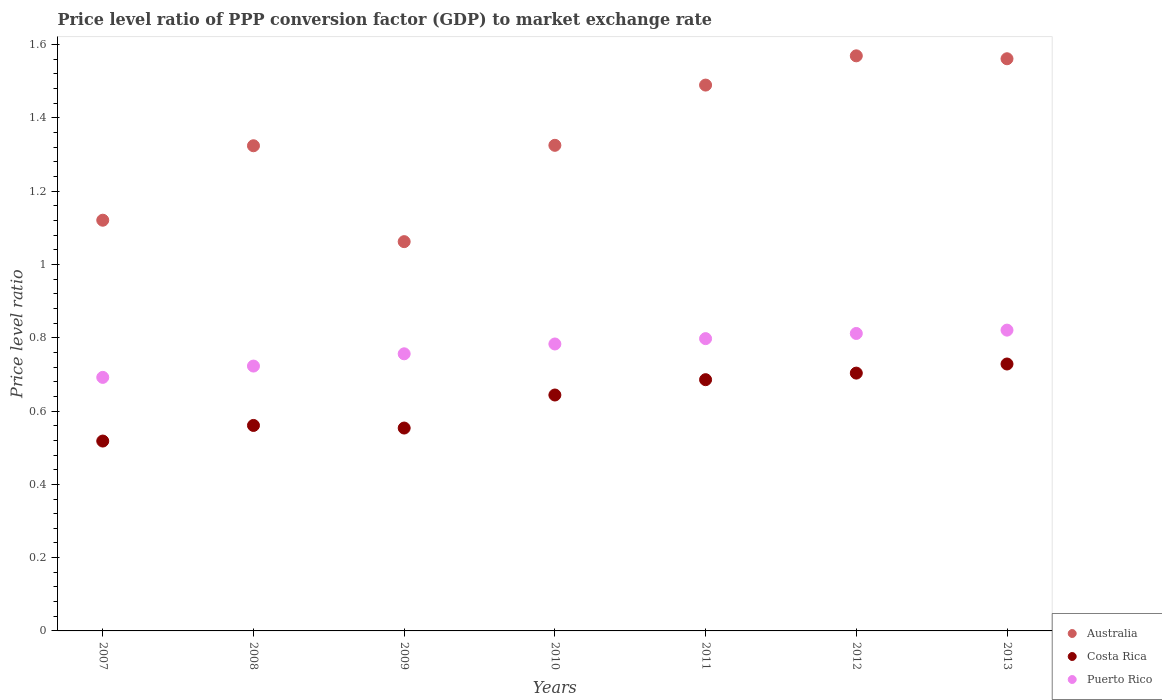Is the number of dotlines equal to the number of legend labels?
Your answer should be very brief. Yes. What is the price level ratio in Costa Rica in 2009?
Offer a very short reply. 0.55. Across all years, what is the maximum price level ratio in Costa Rica?
Ensure brevity in your answer.  0.73. Across all years, what is the minimum price level ratio in Puerto Rico?
Provide a succinct answer. 0.69. In which year was the price level ratio in Costa Rica minimum?
Provide a short and direct response. 2007. What is the total price level ratio in Puerto Rico in the graph?
Your answer should be compact. 5.38. What is the difference between the price level ratio in Australia in 2010 and that in 2013?
Provide a succinct answer. -0.24. What is the difference between the price level ratio in Puerto Rico in 2013 and the price level ratio in Australia in 2009?
Ensure brevity in your answer.  -0.24. What is the average price level ratio in Australia per year?
Make the answer very short. 1.35. In the year 2007, what is the difference between the price level ratio in Australia and price level ratio in Puerto Rico?
Provide a succinct answer. 0.43. In how many years, is the price level ratio in Australia greater than 0.7200000000000001?
Keep it short and to the point. 7. What is the ratio of the price level ratio in Puerto Rico in 2009 to that in 2011?
Give a very brief answer. 0.95. What is the difference between the highest and the second highest price level ratio in Australia?
Your answer should be compact. 0.01. What is the difference between the highest and the lowest price level ratio in Puerto Rico?
Your answer should be very brief. 0.13. In how many years, is the price level ratio in Costa Rica greater than the average price level ratio in Costa Rica taken over all years?
Provide a succinct answer. 4. Is the price level ratio in Costa Rica strictly greater than the price level ratio in Puerto Rico over the years?
Your response must be concise. No. Is the price level ratio in Australia strictly less than the price level ratio in Costa Rica over the years?
Offer a terse response. No. What is the difference between two consecutive major ticks on the Y-axis?
Your response must be concise. 0.2. Are the values on the major ticks of Y-axis written in scientific E-notation?
Your response must be concise. No. Does the graph contain grids?
Your answer should be very brief. No. Where does the legend appear in the graph?
Make the answer very short. Bottom right. What is the title of the graph?
Offer a terse response. Price level ratio of PPP conversion factor (GDP) to market exchange rate. What is the label or title of the X-axis?
Provide a short and direct response. Years. What is the label or title of the Y-axis?
Offer a very short reply. Price level ratio. What is the Price level ratio in Australia in 2007?
Your answer should be compact. 1.12. What is the Price level ratio of Costa Rica in 2007?
Provide a short and direct response. 0.52. What is the Price level ratio of Puerto Rico in 2007?
Keep it short and to the point. 0.69. What is the Price level ratio in Australia in 2008?
Keep it short and to the point. 1.32. What is the Price level ratio of Costa Rica in 2008?
Your answer should be compact. 0.56. What is the Price level ratio of Puerto Rico in 2008?
Ensure brevity in your answer.  0.72. What is the Price level ratio in Australia in 2009?
Offer a terse response. 1.06. What is the Price level ratio in Costa Rica in 2009?
Keep it short and to the point. 0.55. What is the Price level ratio of Puerto Rico in 2009?
Offer a very short reply. 0.76. What is the Price level ratio in Australia in 2010?
Provide a succinct answer. 1.33. What is the Price level ratio of Costa Rica in 2010?
Your answer should be compact. 0.64. What is the Price level ratio in Puerto Rico in 2010?
Offer a very short reply. 0.78. What is the Price level ratio of Australia in 2011?
Offer a very short reply. 1.49. What is the Price level ratio of Costa Rica in 2011?
Make the answer very short. 0.69. What is the Price level ratio in Puerto Rico in 2011?
Keep it short and to the point. 0.8. What is the Price level ratio in Australia in 2012?
Offer a terse response. 1.57. What is the Price level ratio of Costa Rica in 2012?
Offer a terse response. 0.7. What is the Price level ratio of Puerto Rico in 2012?
Provide a short and direct response. 0.81. What is the Price level ratio of Australia in 2013?
Ensure brevity in your answer.  1.56. What is the Price level ratio of Costa Rica in 2013?
Your answer should be compact. 0.73. What is the Price level ratio in Puerto Rico in 2013?
Give a very brief answer. 0.82. Across all years, what is the maximum Price level ratio of Australia?
Offer a terse response. 1.57. Across all years, what is the maximum Price level ratio of Costa Rica?
Make the answer very short. 0.73. Across all years, what is the maximum Price level ratio of Puerto Rico?
Offer a terse response. 0.82. Across all years, what is the minimum Price level ratio of Australia?
Offer a very short reply. 1.06. Across all years, what is the minimum Price level ratio in Costa Rica?
Offer a terse response. 0.52. Across all years, what is the minimum Price level ratio in Puerto Rico?
Offer a terse response. 0.69. What is the total Price level ratio of Australia in the graph?
Give a very brief answer. 9.45. What is the total Price level ratio of Costa Rica in the graph?
Provide a succinct answer. 4.39. What is the total Price level ratio in Puerto Rico in the graph?
Your response must be concise. 5.38. What is the difference between the Price level ratio of Australia in 2007 and that in 2008?
Provide a succinct answer. -0.2. What is the difference between the Price level ratio of Costa Rica in 2007 and that in 2008?
Offer a very short reply. -0.04. What is the difference between the Price level ratio of Puerto Rico in 2007 and that in 2008?
Your answer should be very brief. -0.03. What is the difference between the Price level ratio in Australia in 2007 and that in 2009?
Keep it short and to the point. 0.06. What is the difference between the Price level ratio of Costa Rica in 2007 and that in 2009?
Provide a succinct answer. -0.04. What is the difference between the Price level ratio in Puerto Rico in 2007 and that in 2009?
Keep it short and to the point. -0.06. What is the difference between the Price level ratio in Australia in 2007 and that in 2010?
Offer a very short reply. -0.2. What is the difference between the Price level ratio of Costa Rica in 2007 and that in 2010?
Provide a short and direct response. -0.13. What is the difference between the Price level ratio in Puerto Rico in 2007 and that in 2010?
Make the answer very short. -0.09. What is the difference between the Price level ratio of Australia in 2007 and that in 2011?
Provide a succinct answer. -0.37. What is the difference between the Price level ratio of Costa Rica in 2007 and that in 2011?
Give a very brief answer. -0.17. What is the difference between the Price level ratio in Puerto Rico in 2007 and that in 2011?
Your response must be concise. -0.11. What is the difference between the Price level ratio in Australia in 2007 and that in 2012?
Your answer should be compact. -0.45. What is the difference between the Price level ratio in Costa Rica in 2007 and that in 2012?
Offer a terse response. -0.19. What is the difference between the Price level ratio of Puerto Rico in 2007 and that in 2012?
Your response must be concise. -0.12. What is the difference between the Price level ratio in Australia in 2007 and that in 2013?
Provide a succinct answer. -0.44. What is the difference between the Price level ratio of Costa Rica in 2007 and that in 2013?
Your response must be concise. -0.21. What is the difference between the Price level ratio in Puerto Rico in 2007 and that in 2013?
Ensure brevity in your answer.  -0.13. What is the difference between the Price level ratio of Australia in 2008 and that in 2009?
Provide a short and direct response. 0.26. What is the difference between the Price level ratio of Costa Rica in 2008 and that in 2009?
Your answer should be compact. 0.01. What is the difference between the Price level ratio in Puerto Rico in 2008 and that in 2009?
Your answer should be very brief. -0.03. What is the difference between the Price level ratio of Australia in 2008 and that in 2010?
Your answer should be compact. -0. What is the difference between the Price level ratio of Costa Rica in 2008 and that in 2010?
Your answer should be compact. -0.08. What is the difference between the Price level ratio in Puerto Rico in 2008 and that in 2010?
Your answer should be compact. -0.06. What is the difference between the Price level ratio of Australia in 2008 and that in 2011?
Provide a short and direct response. -0.17. What is the difference between the Price level ratio in Costa Rica in 2008 and that in 2011?
Make the answer very short. -0.12. What is the difference between the Price level ratio in Puerto Rico in 2008 and that in 2011?
Give a very brief answer. -0.07. What is the difference between the Price level ratio in Australia in 2008 and that in 2012?
Your answer should be compact. -0.25. What is the difference between the Price level ratio in Costa Rica in 2008 and that in 2012?
Ensure brevity in your answer.  -0.14. What is the difference between the Price level ratio in Puerto Rico in 2008 and that in 2012?
Make the answer very short. -0.09. What is the difference between the Price level ratio of Australia in 2008 and that in 2013?
Provide a succinct answer. -0.24. What is the difference between the Price level ratio of Costa Rica in 2008 and that in 2013?
Provide a short and direct response. -0.17. What is the difference between the Price level ratio in Puerto Rico in 2008 and that in 2013?
Your answer should be very brief. -0.1. What is the difference between the Price level ratio of Australia in 2009 and that in 2010?
Your answer should be very brief. -0.26. What is the difference between the Price level ratio in Costa Rica in 2009 and that in 2010?
Offer a terse response. -0.09. What is the difference between the Price level ratio of Puerto Rico in 2009 and that in 2010?
Make the answer very short. -0.03. What is the difference between the Price level ratio in Australia in 2009 and that in 2011?
Your response must be concise. -0.43. What is the difference between the Price level ratio in Costa Rica in 2009 and that in 2011?
Make the answer very short. -0.13. What is the difference between the Price level ratio of Puerto Rico in 2009 and that in 2011?
Make the answer very short. -0.04. What is the difference between the Price level ratio in Australia in 2009 and that in 2012?
Your answer should be compact. -0.51. What is the difference between the Price level ratio in Costa Rica in 2009 and that in 2012?
Your answer should be compact. -0.15. What is the difference between the Price level ratio of Puerto Rico in 2009 and that in 2012?
Offer a very short reply. -0.06. What is the difference between the Price level ratio of Australia in 2009 and that in 2013?
Offer a terse response. -0.5. What is the difference between the Price level ratio of Costa Rica in 2009 and that in 2013?
Offer a very short reply. -0.17. What is the difference between the Price level ratio of Puerto Rico in 2009 and that in 2013?
Offer a terse response. -0.06. What is the difference between the Price level ratio of Australia in 2010 and that in 2011?
Your answer should be compact. -0.16. What is the difference between the Price level ratio of Costa Rica in 2010 and that in 2011?
Your answer should be compact. -0.04. What is the difference between the Price level ratio in Puerto Rico in 2010 and that in 2011?
Give a very brief answer. -0.01. What is the difference between the Price level ratio of Australia in 2010 and that in 2012?
Your answer should be compact. -0.24. What is the difference between the Price level ratio in Costa Rica in 2010 and that in 2012?
Make the answer very short. -0.06. What is the difference between the Price level ratio in Puerto Rico in 2010 and that in 2012?
Provide a short and direct response. -0.03. What is the difference between the Price level ratio in Australia in 2010 and that in 2013?
Your response must be concise. -0.24. What is the difference between the Price level ratio in Costa Rica in 2010 and that in 2013?
Your response must be concise. -0.08. What is the difference between the Price level ratio in Puerto Rico in 2010 and that in 2013?
Make the answer very short. -0.04. What is the difference between the Price level ratio in Australia in 2011 and that in 2012?
Ensure brevity in your answer.  -0.08. What is the difference between the Price level ratio in Costa Rica in 2011 and that in 2012?
Make the answer very short. -0.02. What is the difference between the Price level ratio of Puerto Rico in 2011 and that in 2012?
Your response must be concise. -0.01. What is the difference between the Price level ratio in Australia in 2011 and that in 2013?
Offer a terse response. -0.07. What is the difference between the Price level ratio in Costa Rica in 2011 and that in 2013?
Your answer should be very brief. -0.04. What is the difference between the Price level ratio of Puerto Rico in 2011 and that in 2013?
Keep it short and to the point. -0.02. What is the difference between the Price level ratio in Australia in 2012 and that in 2013?
Ensure brevity in your answer.  0.01. What is the difference between the Price level ratio of Costa Rica in 2012 and that in 2013?
Your response must be concise. -0.02. What is the difference between the Price level ratio in Puerto Rico in 2012 and that in 2013?
Offer a terse response. -0.01. What is the difference between the Price level ratio of Australia in 2007 and the Price level ratio of Costa Rica in 2008?
Make the answer very short. 0.56. What is the difference between the Price level ratio in Australia in 2007 and the Price level ratio in Puerto Rico in 2008?
Make the answer very short. 0.4. What is the difference between the Price level ratio in Costa Rica in 2007 and the Price level ratio in Puerto Rico in 2008?
Provide a short and direct response. -0.2. What is the difference between the Price level ratio in Australia in 2007 and the Price level ratio in Costa Rica in 2009?
Keep it short and to the point. 0.57. What is the difference between the Price level ratio of Australia in 2007 and the Price level ratio of Puerto Rico in 2009?
Offer a terse response. 0.36. What is the difference between the Price level ratio of Costa Rica in 2007 and the Price level ratio of Puerto Rico in 2009?
Your answer should be very brief. -0.24. What is the difference between the Price level ratio of Australia in 2007 and the Price level ratio of Costa Rica in 2010?
Make the answer very short. 0.48. What is the difference between the Price level ratio in Australia in 2007 and the Price level ratio in Puerto Rico in 2010?
Make the answer very short. 0.34. What is the difference between the Price level ratio of Costa Rica in 2007 and the Price level ratio of Puerto Rico in 2010?
Your answer should be compact. -0.26. What is the difference between the Price level ratio in Australia in 2007 and the Price level ratio in Costa Rica in 2011?
Provide a succinct answer. 0.44. What is the difference between the Price level ratio of Australia in 2007 and the Price level ratio of Puerto Rico in 2011?
Your answer should be very brief. 0.32. What is the difference between the Price level ratio of Costa Rica in 2007 and the Price level ratio of Puerto Rico in 2011?
Offer a terse response. -0.28. What is the difference between the Price level ratio in Australia in 2007 and the Price level ratio in Costa Rica in 2012?
Ensure brevity in your answer.  0.42. What is the difference between the Price level ratio of Australia in 2007 and the Price level ratio of Puerto Rico in 2012?
Your answer should be compact. 0.31. What is the difference between the Price level ratio of Costa Rica in 2007 and the Price level ratio of Puerto Rico in 2012?
Keep it short and to the point. -0.29. What is the difference between the Price level ratio of Australia in 2007 and the Price level ratio of Costa Rica in 2013?
Offer a terse response. 0.39. What is the difference between the Price level ratio in Costa Rica in 2007 and the Price level ratio in Puerto Rico in 2013?
Provide a succinct answer. -0.3. What is the difference between the Price level ratio in Australia in 2008 and the Price level ratio in Costa Rica in 2009?
Provide a short and direct response. 0.77. What is the difference between the Price level ratio in Australia in 2008 and the Price level ratio in Puerto Rico in 2009?
Offer a very short reply. 0.57. What is the difference between the Price level ratio of Costa Rica in 2008 and the Price level ratio of Puerto Rico in 2009?
Provide a succinct answer. -0.2. What is the difference between the Price level ratio in Australia in 2008 and the Price level ratio in Costa Rica in 2010?
Offer a very short reply. 0.68. What is the difference between the Price level ratio of Australia in 2008 and the Price level ratio of Puerto Rico in 2010?
Give a very brief answer. 0.54. What is the difference between the Price level ratio of Costa Rica in 2008 and the Price level ratio of Puerto Rico in 2010?
Your response must be concise. -0.22. What is the difference between the Price level ratio in Australia in 2008 and the Price level ratio in Costa Rica in 2011?
Keep it short and to the point. 0.64. What is the difference between the Price level ratio in Australia in 2008 and the Price level ratio in Puerto Rico in 2011?
Your answer should be compact. 0.53. What is the difference between the Price level ratio of Costa Rica in 2008 and the Price level ratio of Puerto Rico in 2011?
Provide a short and direct response. -0.24. What is the difference between the Price level ratio of Australia in 2008 and the Price level ratio of Costa Rica in 2012?
Your answer should be compact. 0.62. What is the difference between the Price level ratio of Australia in 2008 and the Price level ratio of Puerto Rico in 2012?
Offer a terse response. 0.51. What is the difference between the Price level ratio in Costa Rica in 2008 and the Price level ratio in Puerto Rico in 2012?
Offer a very short reply. -0.25. What is the difference between the Price level ratio in Australia in 2008 and the Price level ratio in Costa Rica in 2013?
Offer a very short reply. 0.6. What is the difference between the Price level ratio of Australia in 2008 and the Price level ratio of Puerto Rico in 2013?
Provide a succinct answer. 0.5. What is the difference between the Price level ratio in Costa Rica in 2008 and the Price level ratio in Puerto Rico in 2013?
Provide a short and direct response. -0.26. What is the difference between the Price level ratio in Australia in 2009 and the Price level ratio in Costa Rica in 2010?
Provide a short and direct response. 0.42. What is the difference between the Price level ratio in Australia in 2009 and the Price level ratio in Puerto Rico in 2010?
Make the answer very short. 0.28. What is the difference between the Price level ratio of Costa Rica in 2009 and the Price level ratio of Puerto Rico in 2010?
Make the answer very short. -0.23. What is the difference between the Price level ratio in Australia in 2009 and the Price level ratio in Costa Rica in 2011?
Your answer should be very brief. 0.38. What is the difference between the Price level ratio in Australia in 2009 and the Price level ratio in Puerto Rico in 2011?
Offer a terse response. 0.26. What is the difference between the Price level ratio in Costa Rica in 2009 and the Price level ratio in Puerto Rico in 2011?
Your answer should be compact. -0.24. What is the difference between the Price level ratio of Australia in 2009 and the Price level ratio of Costa Rica in 2012?
Provide a short and direct response. 0.36. What is the difference between the Price level ratio of Australia in 2009 and the Price level ratio of Puerto Rico in 2012?
Give a very brief answer. 0.25. What is the difference between the Price level ratio of Costa Rica in 2009 and the Price level ratio of Puerto Rico in 2012?
Provide a succinct answer. -0.26. What is the difference between the Price level ratio of Australia in 2009 and the Price level ratio of Costa Rica in 2013?
Ensure brevity in your answer.  0.33. What is the difference between the Price level ratio in Australia in 2009 and the Price level ratio in Puerto Rico in 2013?
Make the answer very short. 0.24. What is the difference between the Price level ratio in Costa Rica in 2009 and the Price level ratio in Puerto Rico in 2013?
Make the answer very short. -0.27. What is the difference between the Price level ratio of Australia in 2010 and the Price level ratio of Costa Rica in 2011?
Your response must be concise. 0.64. What is the difference between the Price level ratio in Australia in 2010 and the Price level ratio in Puerto Rico in 2011?
Provide a short and direct response. 0.53. What is the difference between the Price level ratio in Costa Rica in 2010 and the Price level ratio in Puerto Rico in 2011?
Make the answer very short. -0.15. What is the difference between the Price level ratio in Australia in 2010 and the Price level ratio in Costa Rica in 2012?
Offer a very short reply. 0.62. What is the difference between the Price level ratio in Australia in 2010 and the Price level ratio in Puerto Rico in 2012?
Ensure brevity in your answer.  0.51. What is the difference between the Price level ratio in Costa Rica in 2010 and the Price level ratio in Puerto Rico in 2012?
Offer a very short reply. -0.17. What is the difference between the Price level ratio of Australia in 2010 and the Price level ratio of Costa Rica in 2013?
Your response must be concise. 0.6. What is the difference between the Price level ratio in Australia in 2010 and the Price level ratio in Puerto Rico in 2013?
Provide a succinct answer. 0.5. What is the difference between the Price level ratio in Costa Rica in 2010 and the Price level ratio in Puerto Rico in 2013?
Offer a terse response. -0.18. What is the difference between the Price level ratio in Australia in 2011 and the Price level ratio in Costa Rica in 2012?
Give a very brief answer. 0.79. What is the difference between the Price level ratio in Australia in 2011 and the Price level ratio in Puerto Rico in 2012?
Ensure brevity in your answer.  0.68. What is the difference between the Price level ratio in Costa Rica in 2011 and the Price level ratio in Puerto Rico in 2012?
Ensure brevity in your answer.  -0.13. What is the difference between the Price level ratio of Australia in 2011 and the Price level ratio of Costa Rica in 2013?
Provide a short and direct response. 0.76. What is the difference between the Price level ratio of Australia in 2011 and the Price level ratio of Puerto Rico in 2013?
Your answer should be very brief. 0.67. What is the difference between the Price level ratio in Costa Rica in 2011 and the Price level ratio in Puerto Rico in 2013?
Offer a very short reply. -0.14. What is the difference between the Price level ratio in Australia in 2012 and the Price level ratio in Costa Rica in 2013?
Provide a succinct answer. 0.84. What is the difference between the Price level ratio in Australia in 2012 and the Price level ratio in Puerto Rico in 2013?
Offer a terse response. 0.75. What is the difference between the Price level ratio of Costa Rica in 2012 and the Price level ratio of Puerto Rico in 2013?
Provide a short and direct response. -0.12. What is the average Price level ratio in Australia per year?
Keep it short and to the point. 1.35. What is the average Price level ratio of Costa Rica per year?
Offer a terse response. 0.63. What is the average Price level ratio of Puerto Rico per year?
Make the answer very short. 0.77. In the year 2007, what is the difference between the Price level ratio of Australia and Price level ratio of Costa Rica?
Your answer should be very brief. 0.6. In the year 2007, what is the difference between the Price level ratio in Australia and Price level ratio in Puerto Rico?
Your response must be concise. 0.43. In the year 2007, what is the difference between the Price level ratio in Costa Rica and Price level ratio in Puerto Rico?
Offer a terse response. -0.17. In the year 2008, what is the difference between the Price level ratio of Australia and Price level ratio of Costa Rica?
Keep it short and to the point. 0.76. In the year 2008, what is the difference between the Price level ratio of Australia and Price level ratio of Puerto Rico?
Give a very brief answer. 0.6. In the year 2008, what is the difference between the Price level ratio of Costa Rica and Price level ratio of Puerto Rico?
Offer a very short reply. -0.16. In the year 2009, what is the difference between the Price level ratio of Australia and Price level ratio of Costa Rica?
Make the answer very short. 0.51. In the year 2009, what is the difference between the Price level ratio in Australia and Price level ratio in Puerto Rico?
Offer a very short reply. 0.31. In the year 2009, what is the difference between the Price level ratio of Costa Rica and Price level ratio of Puerto Rico?
Make the answer very short. -0.2. In the year 2010, what is the difference between the Price level ratio in Australia and Price level ratio in Costa Rica?
Offer a terse response. 0.68. In the year 2010, what is the difference between the Price level ratio in Australia and Price level ratio in Puerto Rico?
Your answer should be very brief. 0.54. In the year 2010, what is the difference between the Price level ratio in Costa Rica and Price level ratio in Puerto Rico?
Provide a short and direct response. -0.14. In the year 2011, what is the difference between the Price level ratio of Australia and Price level ratio of Costa Rica?
Give a very brief answer. 0.8. In the year 2011, what is the difference between the Price level ratio in Australia and Price level ratio in Puerto Rico?
Make the answer very short. 0.69. In the year 2011, what is the difference between the Price level ratio in Costa Rica and Price level ratio in Puerto Rico?
Keep it short and to the point. -0.11. In the year 2012, what is the difference between the Price level ratio in Australia and Price level ratio in Costa Rica?
Give a very brief answer. 0.87. In the year 2012, what is the difference between the Price level ratio in Australia and Price level ratio in Puerto Rico?
Keep it short and to the point. 0.76. In the year 2012, what is the difference between the Price level ratio in Costa Rica and Price level ratio in Puerto Rico?
Offer a very short reply. -0.11. In the year 2013, what is the difference between the Price level ratio of Australia and Price level ratio of Costa Rica?
Provide a succinct answer. 0.83. In the year 2013, what is the difference between the Price level ratio of Australia and Price level ratio of Puerto Rico?
Offer a terse response. 0.74. In the year 2013, what is the difference between the Price level ratio of Costa Rica and Price level ratio of Puerto Rico?
Provide a short and direct response. -0.09. What is the ratio of the Price level ratio of Australia in 2007 to that in 2008?
Provide a succinct answer. 0.85. What is the ratio of the Price level ratio in Costa Rica in 2007 to that in 2008?
Make the answer very short. 0.92. What is the ratio of the Price level ratio of Puerto Rico in 2007 to that in 2008?
Keep it short and to the point. 0.96. What is the ratio of the Price level ratio of Australia in 2007 to that in 2009?
Your answer should be very brief. 1.06. What is the ratio of the Price level ratio in Costa Rica in 2007 to that in 2009?
Offer a very short reply. 0.94. What is the ratio of the Price level ratio in Puerto Rico in 2007 to that in 2009?
Provide a succinct answer. 0.91. What is the ratio of the Price level ratio in Australia in 2007 to that in 2010?
Give a very brief answer. 0.85. What is the ratio of the Price level ratio in Costa Rica in 2007 to that in 2010?
Keep it short and to the point. 0.8. What is the ratio of the Price level ratio in Puerto Rico in 2007 to that in 2010?
Offer a very short reply. 0.88. What is the ratio of the Price level ratio in Australia in 2007 to that in 2011?
Give a very brief answer. 0.75. What is the ratio of the Price level ratio of Costa Rica in 2007 to that in 2011?
Make the answer very short. 0.76. What is the ratio of the Price level ratio of Puerto Rico in 2007 to that in 2011?
Your response must be concise. 0.87. What is the ratio of the Price level ratio of Australia in 2007 to that in 2012?
Offer a very short reply. 0.71. What is the ratio of the Price level ratio in Costa Rica in 2007 to that in 2012?
Offer a very short reply. 0.74. What is the ratio of the Price level ratio of Puerto Rico in 2007 to that in 2012?
Make the answer very short. 0.85. What is the ratio of the Price level ratio of Australia in 2007 to that in 2013?
Your answer should be very brief. 0.72. What is the ratio of the Price level ratio of Costa Rica in 2007 to that in 2013?
Keep it short and to the point. 0.71. What is the ratio of the Price level ratio of Puerto Rico in 2007 to that in 2013?
Give a very brief answer. 0.84. What is the ratio of the Price level ratio in Australia in 2008 to that in 2009?
Your answer should be compact. 1.25. What is the ratio of the Price level ratio of Costa Rica in 2008 to that in 2009?
Give a very brief answer. 1.01. What is the ratio of the Price level ratio in Puerto Rico in 2008 to that in 2009?
Your answer should be very brief. 0.96. What is the ratio of the Price level ratio in Costa Rica in 2008 to that in 2010?
Provide a short and direct response. 0.87. What is the ratio of the Price level ratio in Australia in 2008 to that in 2011?
Your answer should be very brief. 0.89. What is the ratio of the Price level ratio in Costa Rica in 2008 to that in 2011?
Keep it short and to the point. 0.82. What is the ratio of the Price level ratio in Puerto Rico in 2008 to that in 2011?
Ensure brevity in your answer.  0.91. What is the ratio of the Price level ratio of Australia in 2008 to that in 2012?
Your response must be concise. 0.84. What is the ratio of the Price level ratio in Costa Rica in 2008 to that in 2012?
Offer a terse response. 0.8. What is the ratio of the Price level ratio in Puerto Rico in 2008 to that in 2012?
Provide a short and direct response. 0.89. What is the ratio of the Price level ratio of Australia in 2008 to that in 2013?
Provide a short and direct response. 0.85. What is the ratio of the Price level ratio in Costa Rica in 2008 to that in 2013?
Make the answer very short. 0.77. What is the ratio of the Price level ratio in Puerto Rico in 2008 to that in 2013?
Offer a very short reply. 0.88. What is the ratio of the Price level ratio of Australia in 2009 to that in 2010?
Make the answer very short. 0.8. What is the ratio of the Price level ratio in Costa Rica in 2009 to that in 2010?
Offer a terse response. 0.86. What is the ratio of the Price level ratio of Puerto Rico in 2009 to that in 2010?
Ensure brevity in your answer.  0.97. What is the ratio of the Price level ratio in Australia in 2009 to that in 2011?
Your response must be concise. 0.71. What is the ratio of the Price level ratio in Costa Rica in 2009 to that in 2011?
Give a very brief answer. 0.81. What is the ratio of the Price level ratio in Puerto Rico in 2009 to that in 2011?
Ensure brevity in your answer.  0.95. What is the ratio of the Price level ratio in Australia in 2009 to that in 2012?
Keep it short and to the point. 0.68. What is the ratio of the Price level ratio of Costa Rica in 2009 to that in 2012?
Provide a succinct answer. 0.79. What is the ratio of the Price level ratio in Puerto Rico in 2009 to that in 2012?
Provide a short and direct response. 0.93. What is the ratio of the Price level ratio of Australia in 2009 to that in 2013?
Your response must be concise. 0.68. What is the ratio of the Price level ratio in Costa Rica in 2009 to that in 2013?
Offer a terse response. 0.76. What is the ratio of the Price level ratio of Puerto Rico in 2009 to that in 2013?
Keep it short and to the point. 0.92. What is the ratio of the Price level ratio of Australia in 2010 to that in 2011?
Offer a terse response. 0.89. What is the ratio of the Price level ratio in Costa Rica in 2010 to that in 2011?
Give a very brief answer. 0.94. What is the ratio of the Price level ratio in Puerto Rico in 2010 to that in 2011?
Keep it short and to the point. 0.98. What is the ratio of the Price level ratio in Australia in 2010 to that in 2012?
Keep it short and to the point. 0.84. What is the ratio of the Price level ratio in Costa Rica in 2010 to that in 2012?
Your response must be concise. 0.92. What is the ratio of the Price level ratio in Puerto Rico in 2010 to that in 2012?
Keep it short and to the point. 0.96. What is the ratio of the Price level ratio of Australia in 2010 to that in 2013?
Keep it short and to the point. 0.85. What is the ratio of the Price level ratio in Costa Rica in 2010 to that in 2013?
Make the answer very short. 0.88. What is the ratio of the Price level ratio of Puerto Rico in 2010 to that in 2013?
Provide a succinct answer. 0.95. What is the ratio of the Price level ratio of Australia in 2011 to that in 2012?
Offer a very short reply. 0.95. What is the ratio of the Price level ratio of Costa Rica in 2011 to that in 2012?
Your answer should be compact. 0.97. What is the ratio of the Price level ratio of Puerto Rico in 2011 to that in 2012?
Offer a very short reply. 0.98. What is the ratio of the Price level ratio of Australia in 2011 to that in 2013?
Offer a terse response. 0.95. What is the ratio of the Price level ratio of Costa Rica in 2011 to that in 2013?
Make the answer very short. 0.94. What is the ratio of the Price level ratio in Puerto Rico in 2011 to that in 2013?
Make the answer very short. 0.97. What is the ratio of the Price level ratio of Costa Rica in 2012 to that in 2013?
Ensure brevity in your answer.  0.97. What is the ratio of the Price level ratio in Puerto Rico in 2012 to that in 2013?
Provide a short and direct response. 0.99. What is the difference between the highest and the second highest Price level ratio of Australia?
Keep it short and to the point. 0.01. What is the difference between the highest and the second highest Price level ratio of Costa Rica?
Give a very brief answer. 0.02. What is the difference between the highest and the second highest Price level ratio of Puerto Rico?
Make the answer very short. 0.01. What is the difference between the highest and the lowest Price level ratio in Australia?
Your answer should be very brief. 0.51. What is the difference between the highest and the lowest Price level ratio in Costa Rica?
Your response must be concise. 0.21. What is the difference between the highest and the lowest Price level ratio of Puerto Rico?
Offer a terse response. 0.13. 